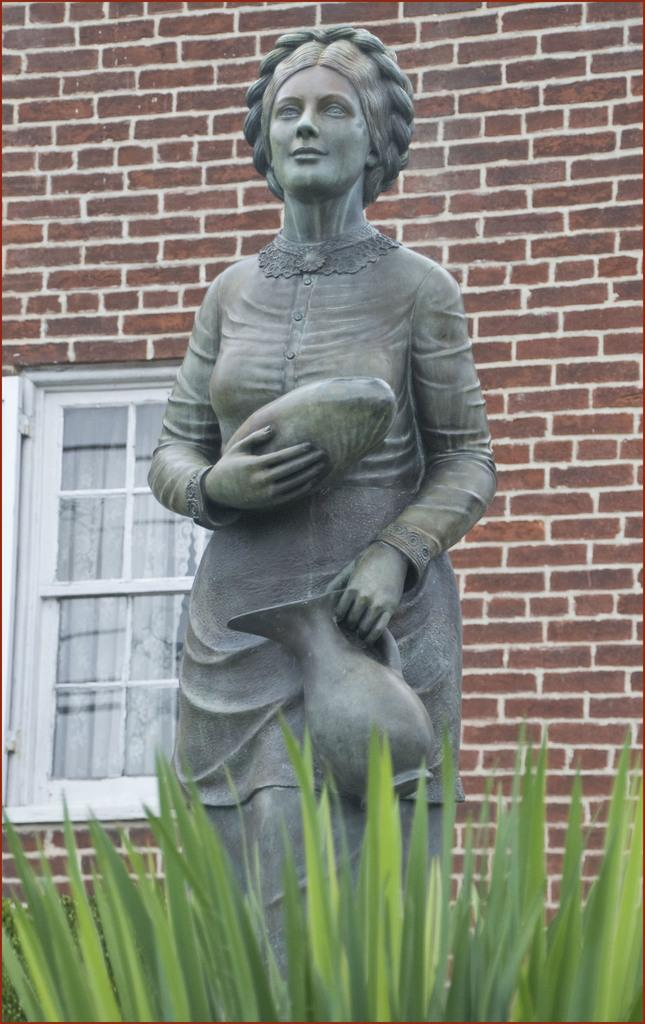What can be seen in the background of the image? There is a window and a wall in the background of the image. What is the statue holding in the image? The statue is holding objects in the image. What type of vegetation is present at the bottom portion of the image? There is a plant at the bottom portion of the image. How many zebras can be seen in the image? There are no zebras present in the image. What type of things can be seen flying in the image? There is no reference to any flying objects or things in the image. 